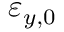<formula> <loc_0><loc_0><loc_500><loc_500>\varepsilon _ { y , 0 }</formula> 